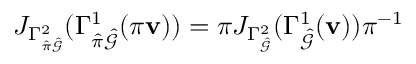<formula> <loc_0><loc_0><loc_500><loc_500>J _ { \Gamma _ { \hat { \pi } \hat { \mathcal { G } } } ^ { 2 } } ( \Gamma _ { \hat { \pi } \hat { \mathcal { G } } } ^ { 1 } ( \pi v ) ) = \pi J _ { \Gamma _ { \hat { \mathcal { G } } } ^ { 2 } } ( \Gamma _ { \hat { \mathcal { G } } } ^ { 1 } ( v ) ) \pi ^ { - 1 }</formula> 